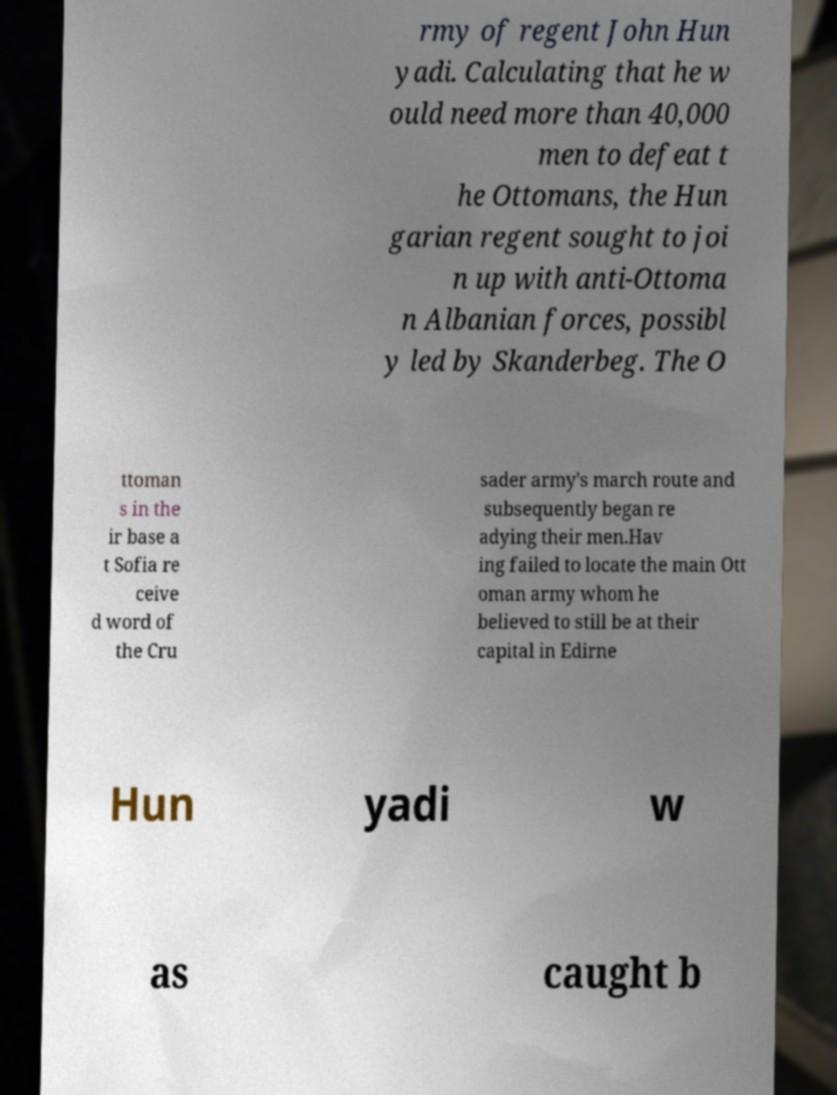I need the written content from this picture converted into text. Can you do that? rmy of regent John Hun yadi. Calculating that he w ould need more than 40,000 men to defeat t he Ottomans, the Hun garian regent sought to joi n up with anti-Ottoma n Albanian forces, possibl y led by Skanderbeg. The O ttoman s in the ir base a t Sofia re ceive d word of the Cru sader army's march route and subsequently began re adying their men.Hav ing failed to locate the main Ott oman army whom he believed to still be at their capital in Edirne Hun yadi w as caught b 